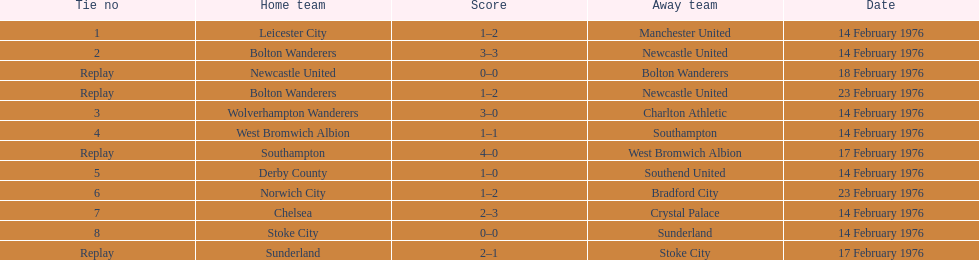Who secured a superior score, manchester united or wolverhampton wanderers? Wolverhampton Wanderers. 